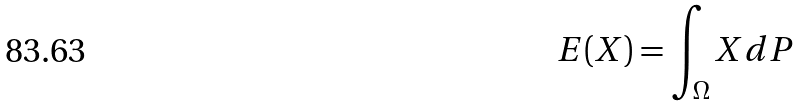Convert formula to latex. <formula><loc_0><loc_0><loc_500><loc_500>E ( X ) = \int _ { \Omega } X d P</formula> 